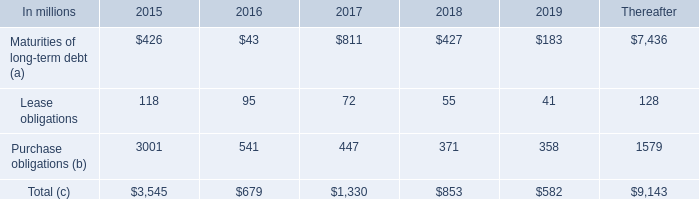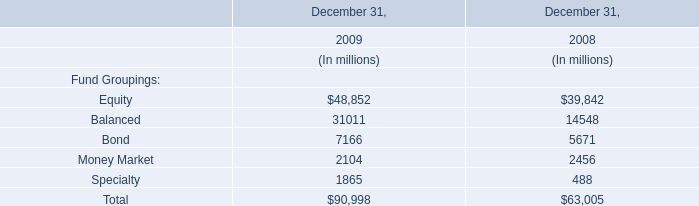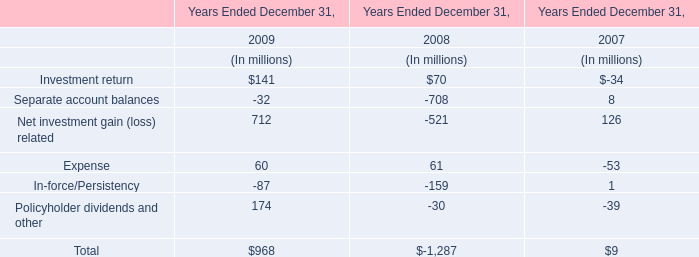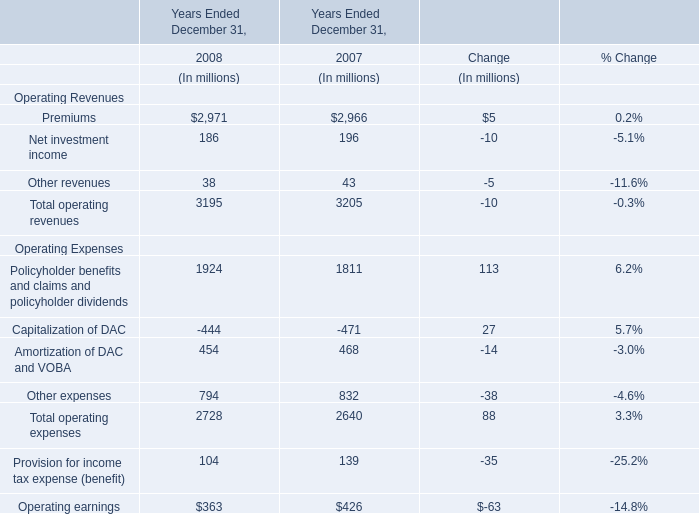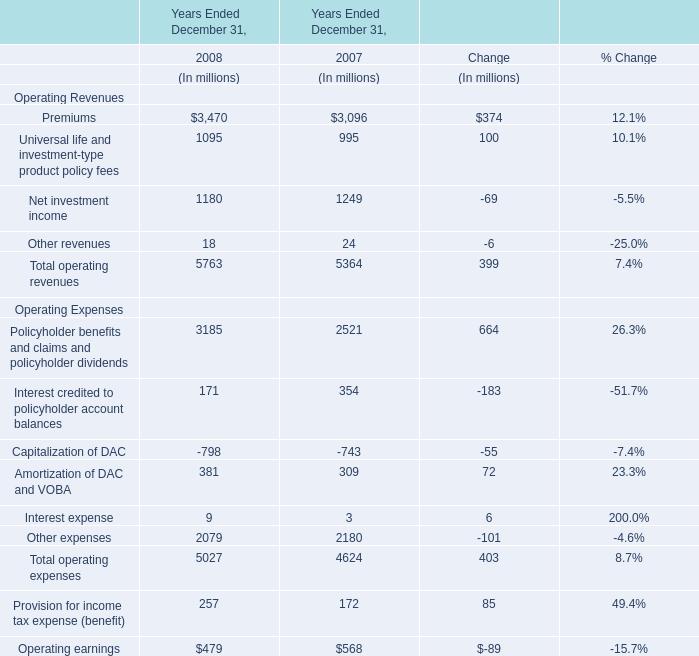In which year is Operating earnings smaller than 500 million? 
Answer: 2008. 